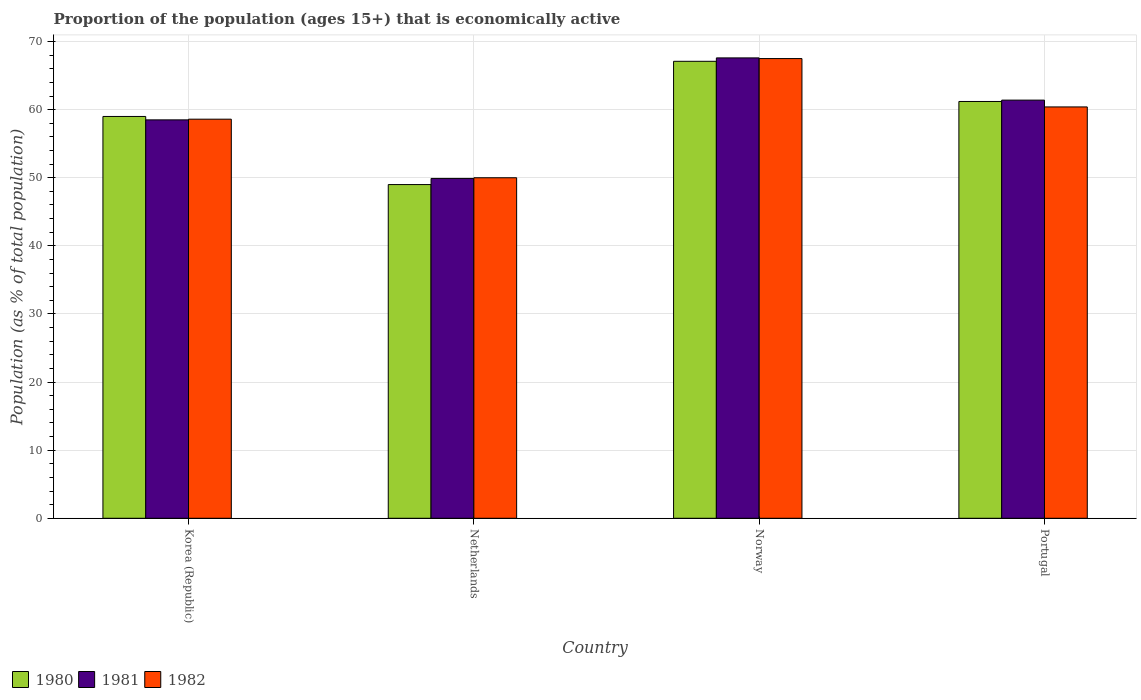How many groups of bars are there?
Make the answer very short. 4. Are the number of bars per tick equal to the number of legend labels?
Give a very brief answer. Yes. How many bars are there on the 1st tick from the left?
Offer a terse response. 3. How many bars are there on the 1st tick from the right?
Ensure brevity in your answer.  3. What is the label of the 4th group of bars from the left?
Provide a succinct answer. Portugal. What is the proportion of the population that is economically active in 1980 in Norway?
Keep it short and to the point. 67.1. Across all countries, what is the maximum proportion of the population that is economically active in 1982?
Offer a very short reply. 67.5. Across all countries, what is the minimum proportion of the population that is economically active in 1980?
Your answer should be very brief. 49. In which country was the proportion of the population that is economically active in 1982 maximum?
Your answer should be very brief. Norway. In which country was the proportion of the population that is economically active in 1982 minimum?
Ensure brevity in your answer.  Netherlands. What is the total proportion of the population that is economically active in 1981 in the graph?
Provide a short and direct response. 237.4. What is the difference between the proportion of the population that is economically active in 1982 in Korea (Republic) and that in Netherlands?
Ensure brevity in your answer.  8.6. What is the difference between the proportion of the population that is economically active in 1981 in Korea (Republic) and the proportion of the population that is economically active in 1980 in Norway?
Make the answer very short. -8.6. What is the average proportion of the population that is economically active in 1982 per country?
Keep it short and to the point. 59.12. What is the difference between the proportion of the population that is economically active of/in 1981 and proportion of the population that is economically active of/in 1980 in Netherlands?
Make the answer very short. 0.9. What is the ratio of the proportion of the population that is economically active in 1982 in Korea (Republic) to that in Netherlands?
Your answer should be compact. 1.17. Is the proportion of the population that is economically active in 1981 in Korea (Republic) less than that in Norway?
Give a very brief answer. Yes. Is the difference between the proportion of the population that is economically active in 1981 in Netherlands and Portugal greater than the difference between the proportion of the population that is economically active in 1980 in Netherlands and Portugal?
Give a very brief answer. Yes. What is the difference between the highest and the second highest proportion of the population that is economically active in 1981?
Ensure brevity in your answer.  -9.1. What is the difference between the highest and the lowest proportion of the population that is economically active in 1981?
Offer a very short reply. 17.7. Is the sum of the proportion of the population that is economically active in 1980 in Korea (Republic) and Portugal greater than the maximum proportion of the population that is economically active in 1981 across all countries?
Offer a terse response. Yes. Is it the case that in every country, the sum of the proportion of the population that is economically active in 1981 and proportion of the population that is economically active in 1980 is greater than the proportion of the population that is economically active in 1982?
Your response must be concise. Yes. How many bars are there?
Your answer should be very brief. 12. How many countries are there in the graph?
Your response must be concise. 4. What is the difference between two consecutive major ticks on the Y-axis?
Offer a very short reply. 10. Are the values on the major ticks of Y-axis written in scientific E-notation?
Keep it short and to the point. No. Does the graph contain grids?
Your answer should be very brief. Yes. How many legend labels are there?
Your answer should be very brief. 3. How are the legend labels stacked?
Offer a very short reply. Horizontal. What is the title of the graph?
Provide a short and direct response. Proportion of the population (ages 15+) that is economically active. What is the label or title of the X-axis?
Give a very brief answer. Country. What is the label or title of the Y-axis?
Your response must be concise. Population (as % of total population). What is the Population (as % of total population) in 1981 in Korea (Republic)?
Your response must be concise. 58.5. What is the Population (as % of total population) of 1982 in Korea (Republic)?
Make the answer very short. 58.6. What is the Population (as % of total population) in 1981 in Netherlands?
Ensure brevity in your answer.  49.9. What is the Population (as % of total population) of 1982 in Netherlands?
Provide a short and direct response. 50. What is the Population (as % of total population) in 1980 in Norway?
Your answer should be compact. 67.1. What is the Population (as % of total population) in 1981 in Norway?
Ensure brevity in your answer.  67.6. What is the Population (as % of total population) of 1982 in Norway?
Offer a very short reply. 67.5. What is the Population (as % of total population) of 1980 in Portugal?
Give a very brief answer. 61.2. What is the Population (as % of total population) of 1981 in Portugal?
Give a very brief answer. 61.4. What is the Population (as % of total population) of 1982 in Portugal?
Keep it short and to the point. 60.4. Across all countries, what is the maximum Population (as % of total population) of 1980?
Keep it short and to the point. 67.1. Across all countries, what is the maximum Population (as % of total population) of 1981?
Your answer should be compact. 67.6. Across all countries, what is the maximum Population (as % of total population) in 1982?
Your response must be concise. 67.5. Across all countries, what is the minimum Population (as % of total population) in 1981?
Offer a very short reply. 49.9. What is the total Population (as % of total population) in 1980 in the graph?
Make the answer very short. 236.3. What is the total Population (as % of total population) in 1981 in the graph?
Give a very brief answer. 237.4. What is the total Population (as % of total population) in 1982 in the graph?
Give a very brief answer. 236.5. What is the difference between the Population (as % of total population) of 1980 in Korea (Republic) and that in Netherlands?
Ensure brevity in your answer.  10. What is the difference between the Population (as % of total population) in 1981 in Korea (Republic) and that in Netherlands?
Your response must be concise. 8.6. What is the difference between the Population (as % of total population) in 1982 in Korea (Republic) and that in Norway?
Keep it short and to the point. -8.9. What is the difference between the Population (as % of total population) in 1980 in Korea (Republic) and that in Portugal?
Offer a terse response. -2.2. What is the difference between the Population (as % of total population) of 1980 in Netherlands and that in Norway?
Provide a short and direct response. -18.1. What is the difference between the Population (as % of total population) of 1981 in Netherlands and that in Norway?
Offer a very short reply. -17.7. What is the difference between the Population (as % of total population) in 1982 in Netherlands and that in Norway?
Keep it short and to the point. -17.5. What is the difference between the Population (as % of total population) in 1980 in Netherlands and that in Portugal?
Your response must be concise. -12.2. What is the difference between the Population (as % of total population) in 1981 in Netherlands and that in Portugal?
Offer a very short reply. -11.5. What is the difference between the Population (as % of total population) in 1982 in Netherlands and that in Portugal?
Offer a very short reply. -10.4. What is the difference between the Population (as % of total population) of 1980 in Norway and that in Portugal?
Provide a succinct answer. 5.9. What is the difference between the Population (as % of total population) of 1981 in Norway and that in Portugal?
Provide a succinct answer. 6.2. What is the difference between the Population (as % of total population) in 1980 in Korea (Republic) and the Population (as % of total population) in 1981 in Netherlands?
Offer a very short reply. 9.1. What is the difference between the Population (as % of total population) in 1980 in Korea (Republic) and the Population (as % of total population) in 1982 in Netherlands?
Offer a very short reply. 9. What is the difference between the Population (as % of total population) of 1980 in Netherlands and the Population (as % of total population) of 1981 in Norway?
Give a very brief answer. -18.6. What is the difference between the Population (as % of total population) of 1980 in Netherlands and the Population (as % of total population) of 1982 in Norway?
Your answer should be compact. -18.5. What is the difference between the Population (as % of total population) of 1981 in Netherlands and the Population (as % of total population) of 1982 in Norway?
Give a very brief answer. -17.6. What is the difference between the Population (as % of total population) in 1980 in Netherlands and the Population (as % of total population) in 1981 in Portugal?
Offer a terse response. -12.4. What is the difference between the Population (as % of total population) in 1980 in Netherlands and the Population (as % of total population) in 1982 in Portugal?
Your answer should be very brief. -11.4. What is the difference between the Population (as % of total population) in 1980 in Norway and the Population (as % of total population) in 1982 in Portugal?
Your answer should be compact. 6.7. What is the difference between the Population (as % of total population) of 1981 in Norway and the Population (as % of total population) of 1982 in Portugal?
Your answer should be compact. 7.2. What is the average Population (as % of total population) in 1980 per country?
Offer a terse response. 59.08. What is the average Population (as % of total population) of 1981 per country?
Provide a succinct answer. 59.35. What is the average Population (as % of total population) of 1982 per country?
Offer a very short reply. 59.12. What is the difference between the Population (as % of total population) in 1980 and Population (as % of total population) in 1982 in Korea (Republic)?
Keep it short and to the point. 0.4. What is the difference between the Population (as % of total population) of 1980 and Population (as % of total population) of 1981 in Netherlands?
Offer a very short reply. -0.9. What is the difference between the Population (as % of total population) in 1980 and Population (as % of total population) in 1982 in Netherlands?
Keep it short and to the point. -1. What is the difference between the Population (as % of total population) of 1980 and Population (as % of total population) of 1981 in Norway?
Your answer should be compact. -0.5. What is the difference between the Population (as % of total population) in 1981 and Population (as % of total population) in 1982 in Norway?
Ensure brevity in your answer.  0.1. What is the difference between the Population (as % of total population) in 1980 and Population (as % of total population) in 1981 in Portugal?
Ensure brevity in your answer.  -0.2. What is the difference between the Population (as % of total population) of 1980 and Population (as % of total population) of 1982 in Portugal?
Provide a succinct answer. 0.8. What is the difference between the Population (as % of total population) in 1981 and Population (as % of total population) in 1982 in Portugal?
Provide a succinct answer. 1. What is the ratio of the Population (as % of total population) of 1980 in Korea (Republic) to that in Netherlands?
Offer a terse response. 1.2. What is the ratio of the Population (as % of total population) of 1981 in Korea (Republic) to that in Netherlands?
Your response must be concise. 1.17. What is the ratio of the Population (as % of total population) of 1982 in Korea (Republic) to that in Netherlands?
Your answer should be compact. 1.17. What is the ratio of the Population (as % of total population) of 1980 in Korea (Republic) to that in Norway?
Your answer should be very brief. 0.88. What is the ratio of the Population (as % of total population) in 1981 in Korea (Republic) to that in Norway?
Ensure brevity in your answer.  0.87. What is the ratio of the Population (as % of total population) in 1982 in Korea (Republic) to that in Norway?
Your response must be concise. 0.87. What is the ratio of the Population (as % of total population) in 1980 in Korea (Republic) to that in Portugal?
Provide a short and direct response. 0.96. What is the ratio of the Population (as % of total population) of 1981 in Korea (Republic) to that in Portugal?
Your answer should be compact. 0.95. What is the ratio of the Population (as % of total population) in 1982 in Korea (Republic) to that in Portugal?
Provide a succinct answer. 0.97. What is the ratio of the Population (as % of total population) of 1980 in Netherlands to that in Norway?
Provide a short and direct response. 0.73. What is the ratio of the Population (as % of total population) in 1981 in Netherlands to that in Norway?
Give a very brief answer. 0.74. What is the ratio of the Population (as % of total population) of 1982 in Netherlands to that in Norway?
Offer a terse response. 0.74. What is the ratio of the Population (as % of total population) of 1980 in Netherlands to that in Portugal?
Provide a short and direct response. 0.8. What is the ratio of the Population (as % of total population) of 1981 in Netherlands to that in Portugal?
Provide a short and direct response. 0.81. What is the ratio of the Population (as % of total population) in 1982 in Netherlands to that in Portugal?
Give a very brief answer. 0.83. What is the ratio of the Population (as % of total population) in 1980 in Norway to that in Portugal?
Offer a terse response. 1.1. What is the ratio of the Population (as % of total population) of 1981 in Norway to that in Portugal?
Offer a very short reply. 1.1. What is the ratio of the Population (as % of total population) in 1982 in Norway to that in Portugal?
Your answer should be compact. 1.12. What is the difference between the highest and the second highest Population (as % of total population) of 1981?
Offer a terse response. 6.2. What is the difference between the highest and the lowest Population (as % of total population) in 1981?
Your answer should be very brief. 17.7. What is the difference between the highest and the lowest Population (as % of total population) of 1982?
Your response must be concise. 17.5. 